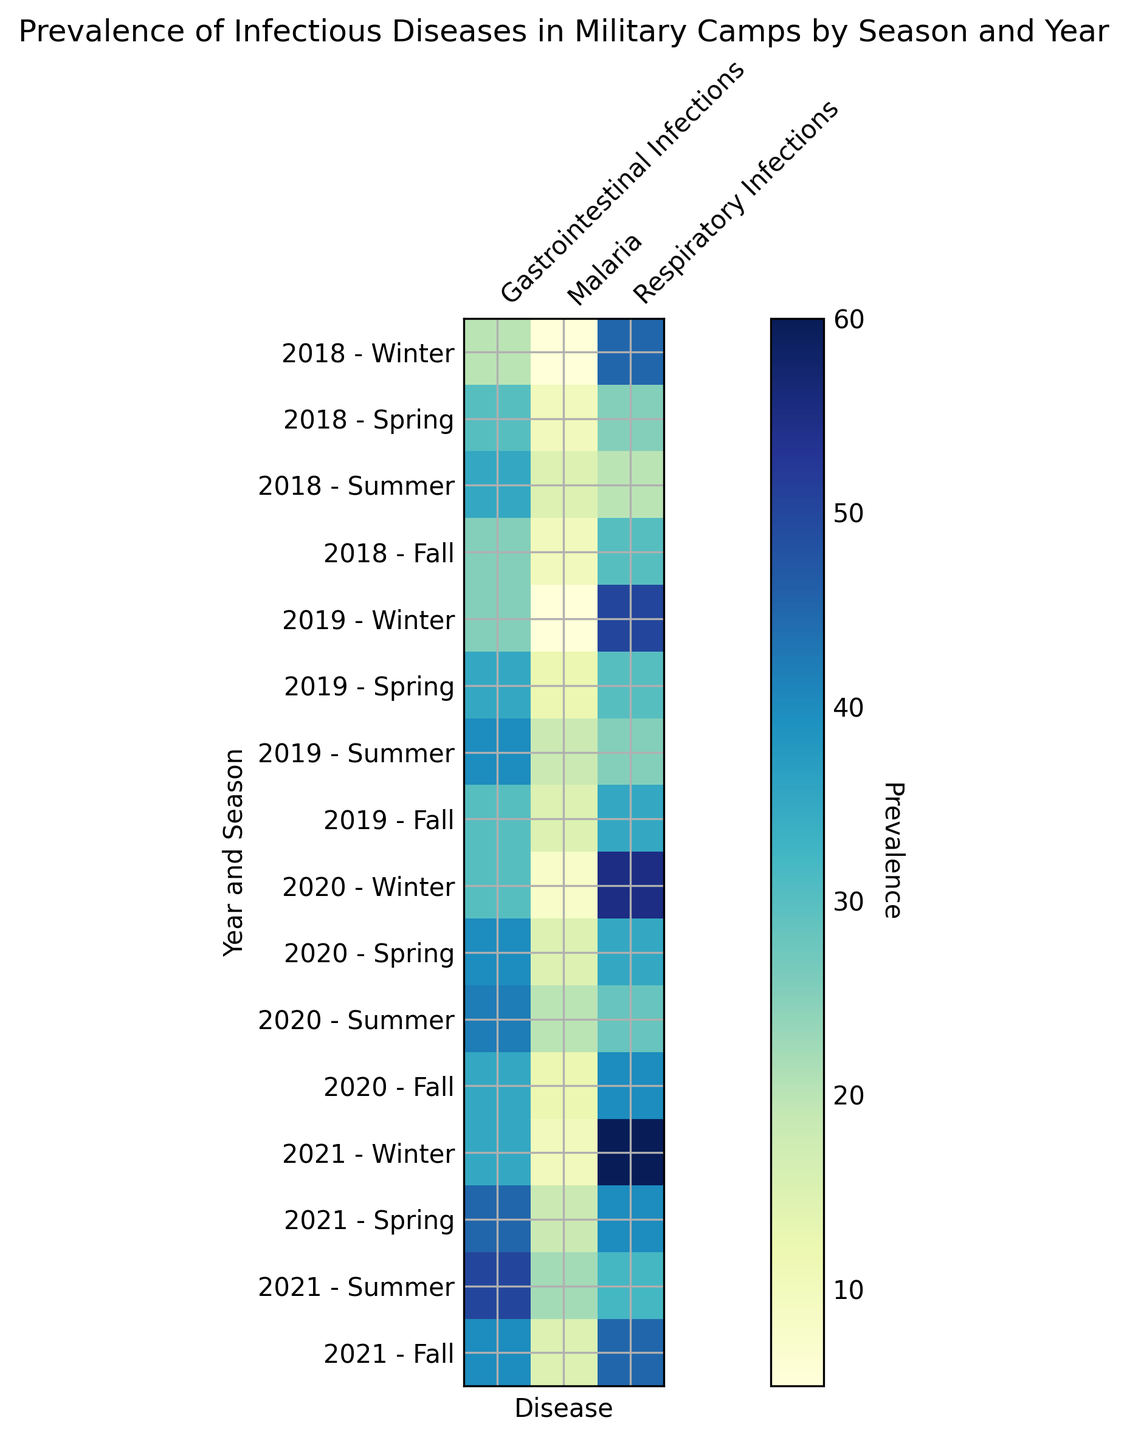What's the season and year with the highest prevalence of respiratory infections? Look for the darkest shade indicating the highest prevalence for respiratory infections. The darkest shade corresponds to Winter of 2021.
Answer: Winter 2021 In which season do gastrointestinal infections tend to peak each year? Compare the shades for gastrointestinal infections across all seasons for each year. Summer consistently shows darker shades, indicating higher prevalence.
Answer: Summer Which year experienced the highest average prevalence of malaria? Calculate the average prevalence of malaria for each year and compare them. The year 2021 has the highest average when summing and averaging the values: (10 + 18 + 22 + 15) / 4 = 16.25.
Answer: 2021 During which year and season was the prevalence of respiratory infections equal to that season's gastrointestinal infections? Scan for seasons where the shades of respiratory infections and gastrointestinal infections align closely. Fall of 2018 and Fall of 2019 both show this matching pattern.
Answer: Fall 2018, Fall 2019 In which season was the prevalence of malaria highest in 2020? Identify the darkest shade for malaria in 2020. The darkest shade corresponds to Summer.
Answer: Summer 2020 How does the prevalence of gastrointestinal infections in Winter of 2019 compare to Winter of 2020? Observe the shades for gastrointestinal infections in Winter of 2019 and Winter of 2020. The shade in Winter of 2020 is darker than that of Winter 2019, indicating a higher prevalence.
Answer: Winter 2020 is higher What is the decline in the prevalence of respiratory infections from Winter to Summer in 2018? Note the values for respiratory infections in Winter and Summer of 2018 (45 and 20 respectively). Calculate the decline: 45 - 20 = 25.
Answer: 25 Is the prevalence of malaria higher in Summer 2019 or Summer 2020? Compare the shades for malaria in Summer 2019 and Summer 2020. The shade is darker in Summer 2020, indicating higher prevalence.
Answer: Summer 2020 Which season in 2021 had the lowest prevalence of malaria? Identify the season with the lightest shade for malaria in 2021. Winter has the lightest shade.
Answer: Winter 2021 What is the sum of the prevalence of gastrointestinal infections in Winter seasons from 2018 to 2021? Add the values for gastrointestinal infections in Winter from all years: 20 (2018) + 25 (2019) + 30 (2020) + 35 (2021) = 110.
Answer: 110 